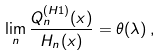<formula> <loc_0><loc_0><loc_500><loc_500>\lim _ { n } \frac { Q _ { n } ^ { ( H 1 ) } ( x ) } { H _ { n } ( x ) } = \theta ( \lambda ) \, ,</formula> 